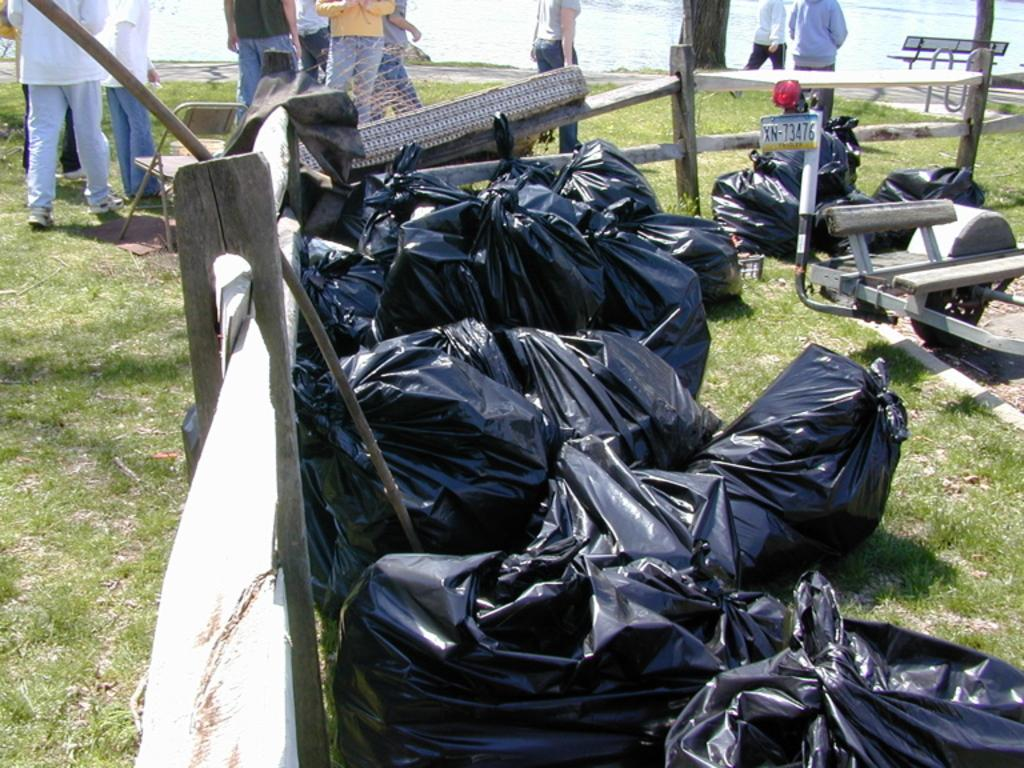What type of bags can be seen in the image? There are black cover bags in the image. Where are the bags located? The bags are inside a wooden fence. What can be seen in the background of the image? There are people walking on the grassland, followed by a lake in the background. What type of control can be seen in the image? There is no control present in the image; it features black cover bags inside a wooden fence and people walking on grassland in the background. 